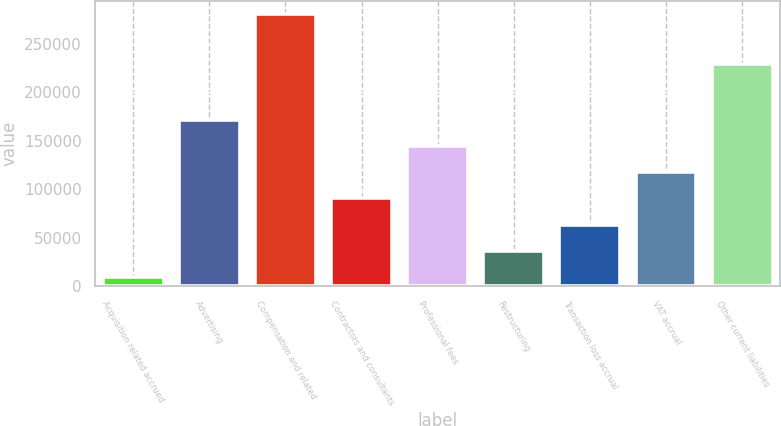<chart> <loc_0><loc_0><loc_500><loc_500><bar_chart><fcel>Acquisition related accrued<fcel>Advertising<fcel>Compensation and related<fcel>Contractors and consultants<fcel>Professional fees<fcel>Restructuring<fcel>Transaction loss accrual<fcel>VAT accrual<fcel>Other current liabilities<nl><fcel>9126<fcel>171918<fcel>280446<fcel>90522<fcel>144786<fcel>36258<fcel>63390<fcel>117654<fcel>229591<nl></chart> 